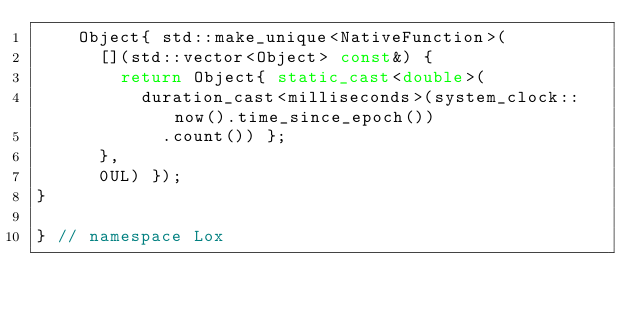<code> <loc_0><loc_0><loc_500><loc_500><_C++_>    Object{ std::make_unique<NativeFunction>(
      [](std::vector<Object> const&) {
        return Object{ static_cast<double>(
          duration_cast<milliseconds>(system_clock::now().time_since_epoch())
            .count()) };
      },
      0UL) });
}

} // namespace Lox</code> 